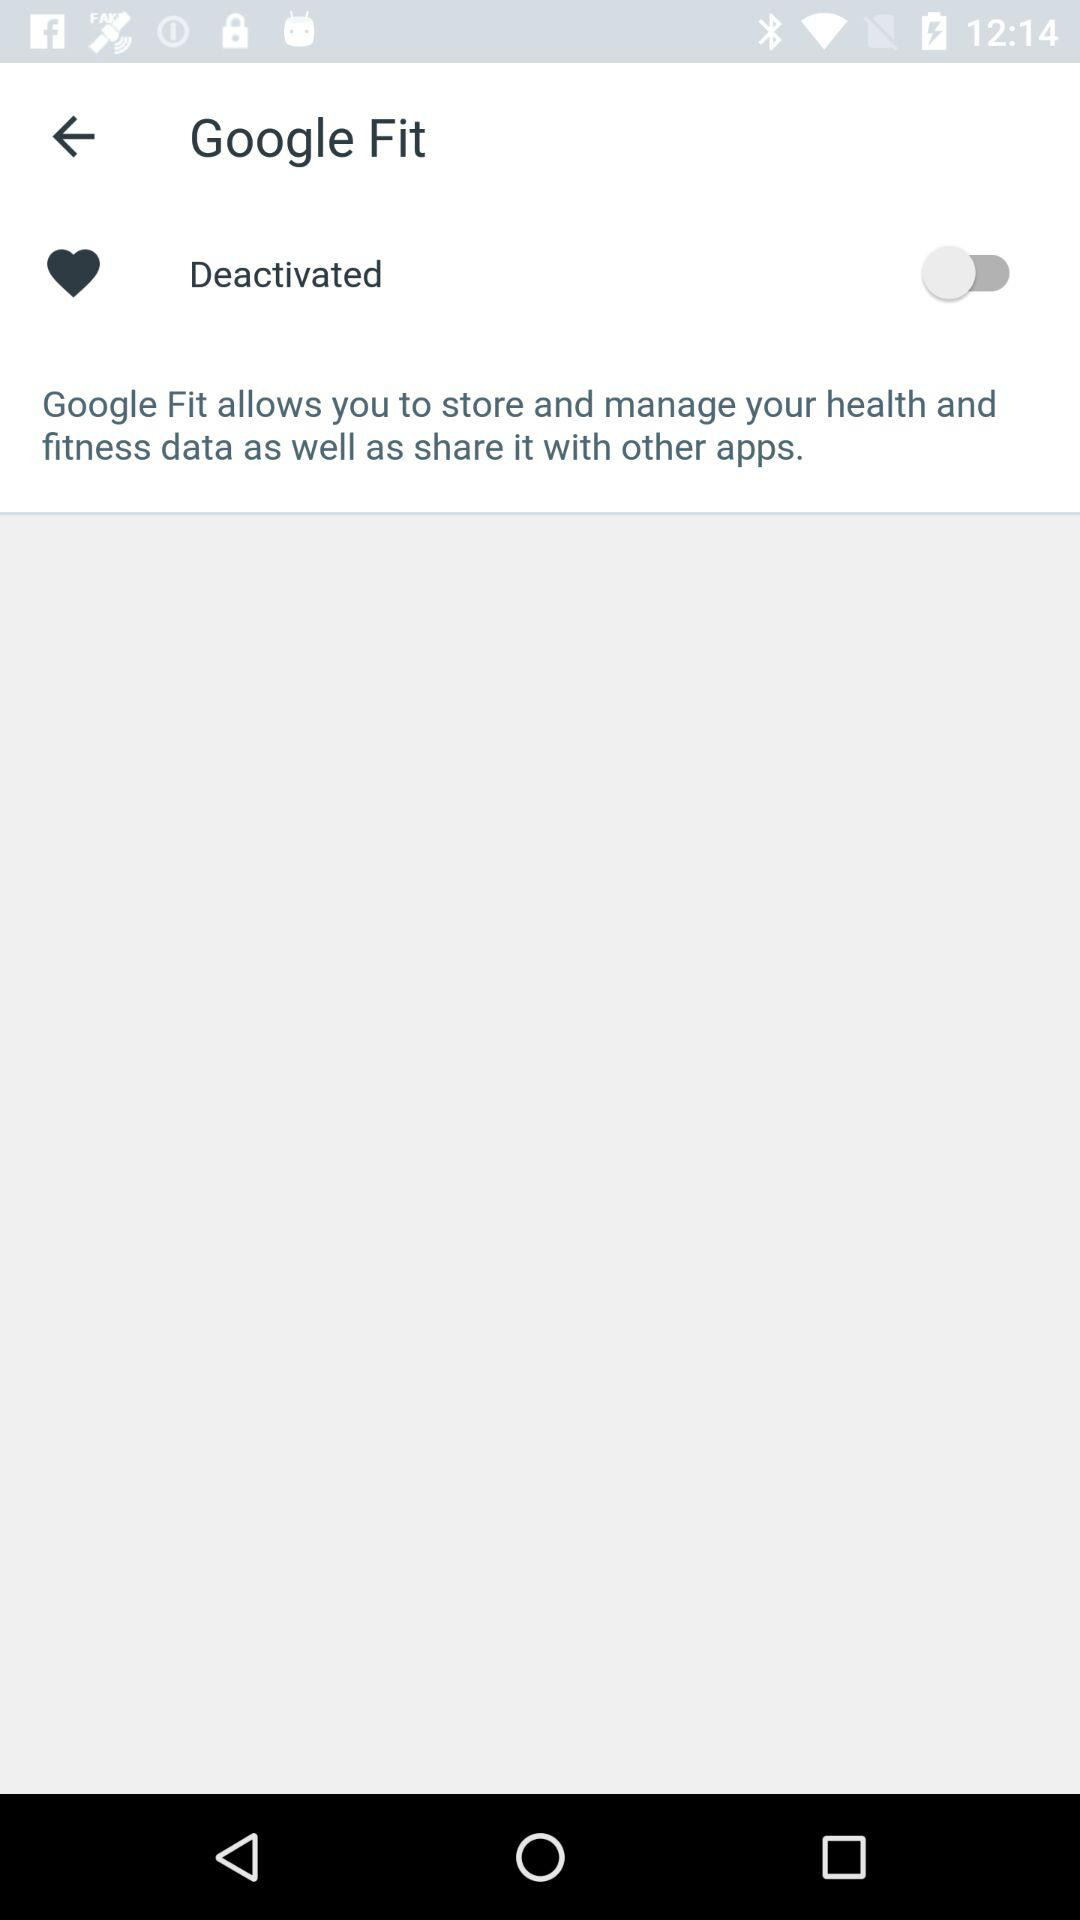Which version of the application is this?
When the provided information is insufficient, respond with <no answer>. <no answer> 